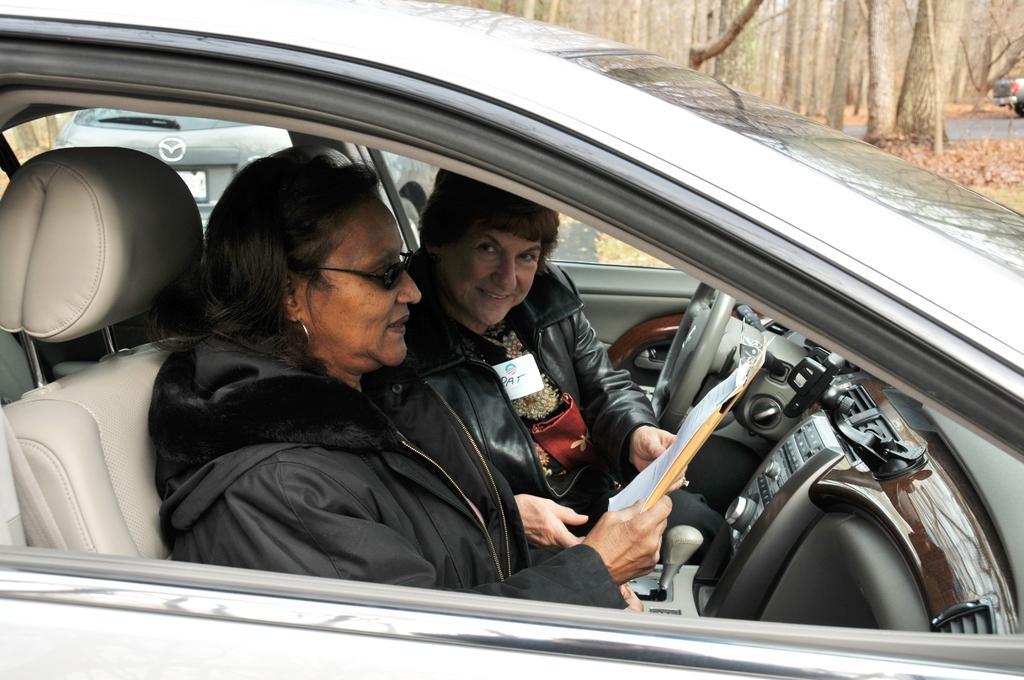Describe this image in one or two sentences. There are two women in black color dress holding a file and sitting in the car. In the background, there is a car, trees, road and grass. 